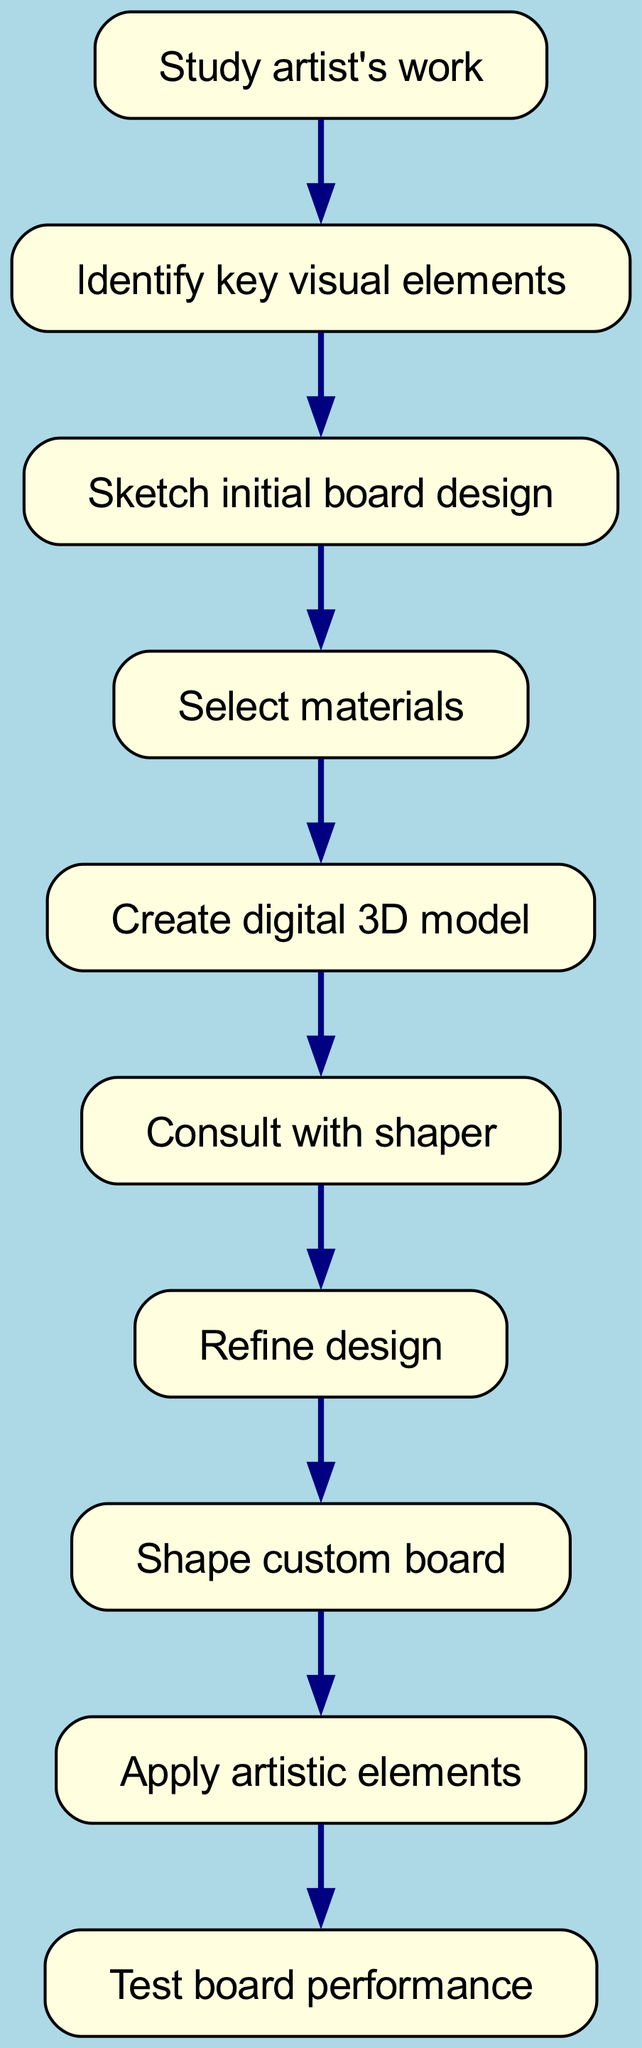What is the first step in the design process? The first step is represented by the node labeled “Study artist's work”, which is the starting point for the entire process.
Answer: Study artist's work How many nodes are there in total? By counting all the unique steps listed in the diagram, there are 10 nodes that represent distinct actions in the process.
Answer: 10 What is the last step before testing the board performance? The node that comes just before “Test board performance” is labeled “Apply artistic elements”, which indicates the action that occurs before the testing phase.
Answer: Apply artistic elements Which step follows after creating a digital 3D model? After looking at the flow from “Create digital 3D model”, the next step proceeds to “Consult with shaper”, as indicated by the directed edge connecting these two nodes.
Answer: Consult with shaper What is the relationship between sketching the initial board design and selecting materials? There is a directed edge from “Sketch initial board design” to “Select materials”, indicating that selecting materials follows the process of sketching.
Answer: Sketch initial board design → Select materials Which steps involve some form of review or refinement? The steps that involve review or refinement in the diagram are “Consult with shaper” and “Refine design”, reflecting the iterative nature of the design process.
Answer: Consult with shaper and Refine design What is the role of the shaper in the design process? The “Consult with shaper” node indicates that the shaper is consulted after creating the digital model to help refine the design before proceeding to physically shape the board.
Answer: Refine design In what sequence are the artistic elements applied in the design process? The artistic elements are applied at the end of the process, specifically after the custom board has been shaped, as shown by the directed edge leading to the “Apply artistic elements” node.
Answer: After shaping the custom board How do the steps connect from studying the artist's work to testing the board performance? The flow starts at “Study artist's work”, followed by identifying key visual elements, sketching the design, selecting materials, creating a digital model, consulting with the shaper, refining design, shaping the board, applying artistic elements, and finally testing performance, forming a linear progression through 10 interconnected steps.
Answer: Sequential connection through 10 steps 